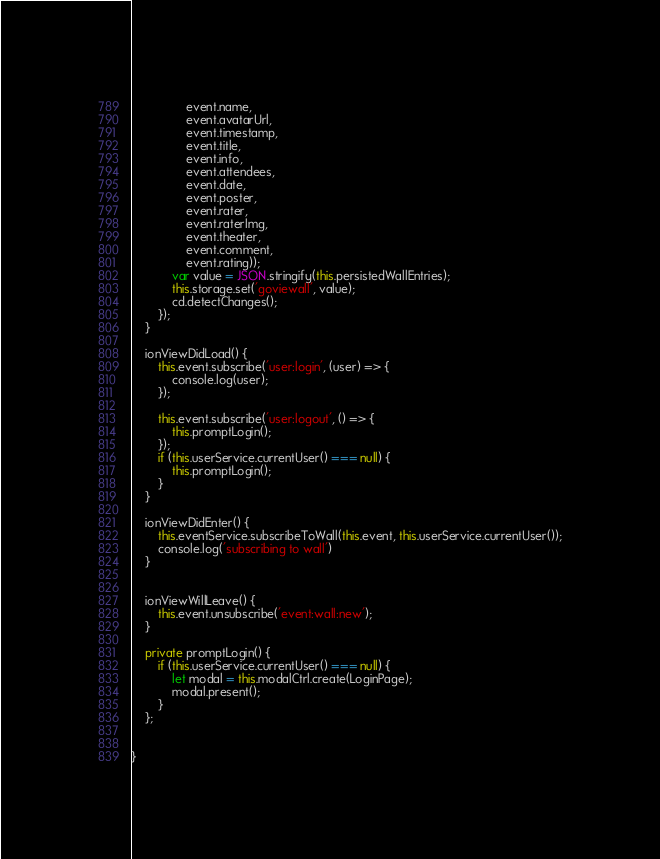Convert code to text. <code><loc_0><loc_0><loc_500><loc_500><_TypeScript_>                event.name,
                event.avatarUrl,
                event.timestamp,
                event.title,
                event.info,
                event.attendees,
                event.date,
                event.poster,
                event.rater,
                event.raterImg,
                event.theater,
                event.comment,
                event.rating));
            var value = JSON.stringify(this.persistedWallEntries);
            this.storage.set('goviewall', value);
            cd.detectChanges();
        });
    }

    ionViewDidLoad() {
        this.event.subscribe('user:login', (user) => {
            console.log(user);
        });

        this.event.subscribe('user:logout', () => {
            this.promptLogin();
        });
        if (this.userService.currentUser() === null) {
            this.promptLogin();
        }
    }

    ionViewDidEnter() {
        this.eventService.subscribeToWall(this.event, this.userService.currentUser());
        console.log('subscribing to wall')
    }


    ionViewWillLeave() {
        this.event.unsubscribe('event:wall:new');
    }

    private promptLogin() {
        if (this.userService.currentUser() === null) {
            let modal = this.modalCtrl.create(LoginPage);
            modal.present();
        }
    };


}
</code> 